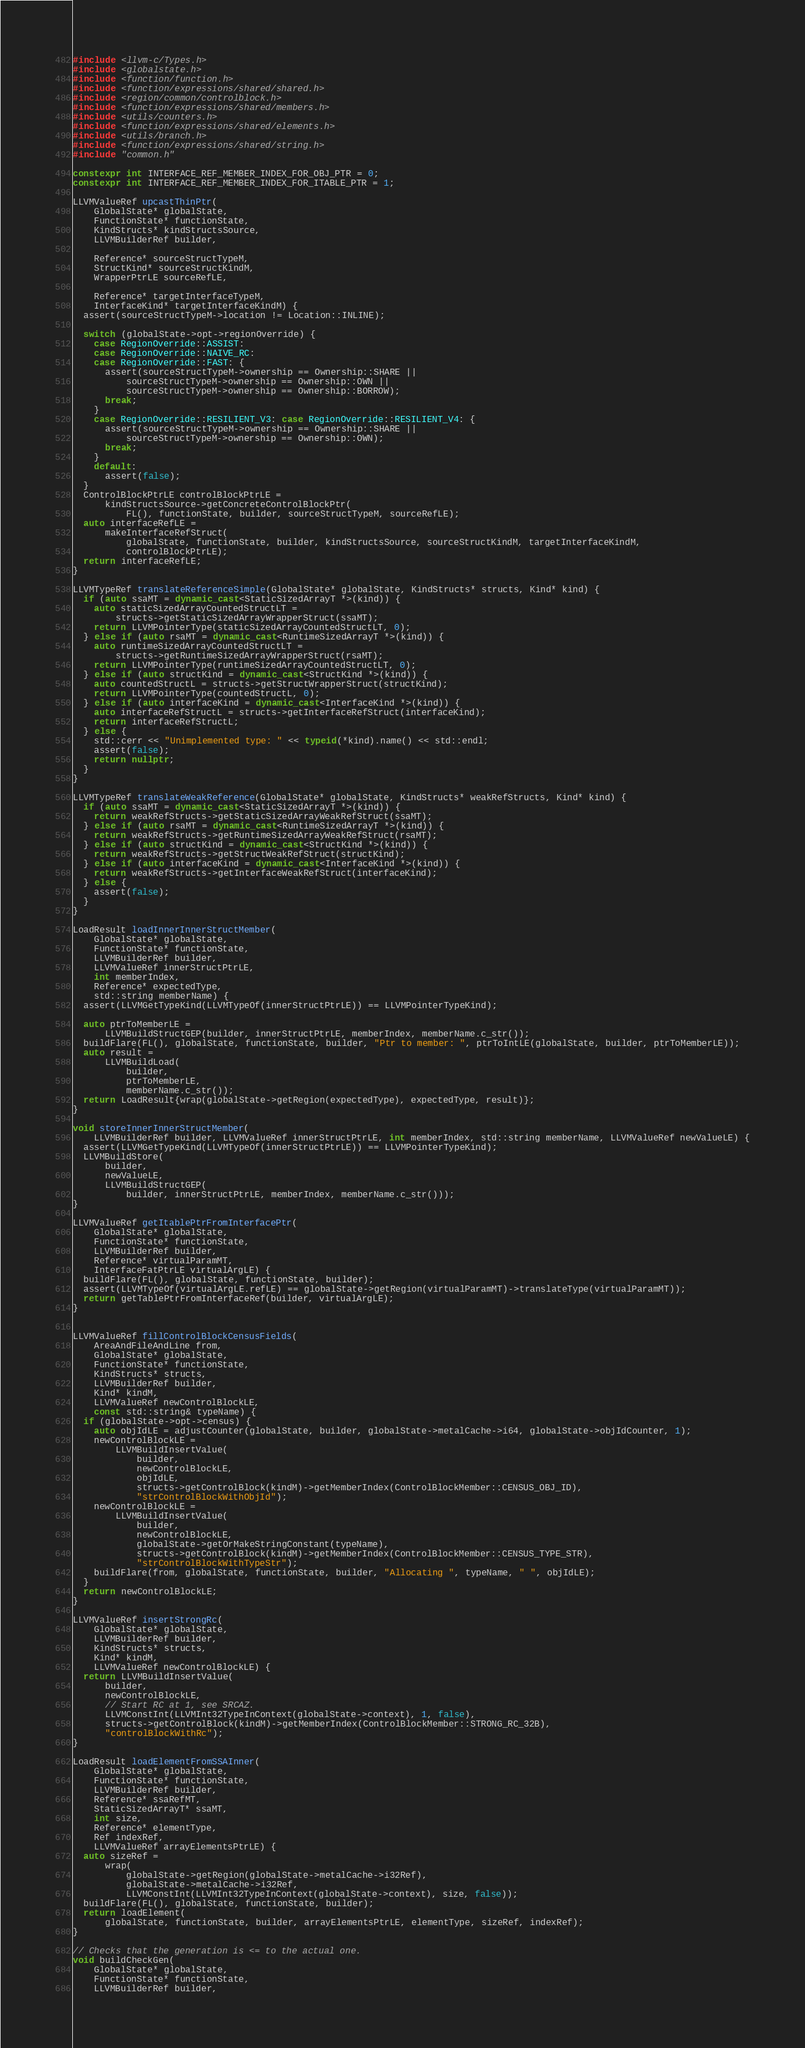Convert code to text. <code><loc_0><loc_0><loc_500><loc_500><_C++_>#include <llvm-c/Types.h>
#include <globalstate.h>
#include <function/function.h>
#include <function/expressions/shared/shared.h>
#include <region/common/controlblock.h>
#include <function/expressions/shared/members.h>
#include <utils/counters.h>
#include <function/expressions/shared/elements.h>
#include <utils/branch.h>
#include <function/expressions/shared/string.h>
#include "common.h"

constexpr int INTERFACE_REF_MEMBER_INDEX_FOR_OBJ_PTR = 0;
constexpr int INTERFACE_REF_MEMBER_INDEX_FOR_ITABLE_PTR = 1;

LLVMValueRef upcastThinPtr(
    GlobalState* globalState,
    FunctionState* functionState,
    KindStructs* kindStructsSource,
    LLVMBuilderRef builder,

    Reference* sourceStructTypeM,
    StructKind* sourceStructKindM,
    WrapperPtrLE sourceRefLE,

    Reference* targetInterfaceTypeM,
    InterfaceKind* targetInterfaceKindM) {
  assert(sourceStructTypeM->location != Location::INLINE);

  switch (globalState->opt->regionOverride) {
    case RegionOverride::ASSIST:
    case RegionOverride::NAIVE_RC:
    case RegionOverride::FAST: {
      assert(sourceStructTypeM->ownership == Ownership::SHARE ||
          sourceStructTypeM->ownership == Ownership::OWN ||
          sourceStructTypeM->ownership == Ownership::BORROW);
      break;
    }
    case RegionOverride::RESILIENT_V3: case RegionOverride::RESILIENT_V4: {
      assert(sourceStructTypeM->ownership == Ownership::SHARE ||
          sourceStructTypeM->ownership == Ownership::OWN);
      break;
    }
    default:
      assert(false);
  }
  ControlBlockPtrLE controlBlockPtrLE =
      kindStructsSource->getConcreteControlBlockPtr(
          FL(), functionState, builder, sourceStructTypeM, sourceRefLE);
  auto interfaceRefLE =
      makeInterfaceRefStruct(
          globalState, functionState, builder, kindStructsSource, sourceStructKindM, targetInterfaceKindM,
          controlBlockPtrLE);
  return interfaceRefLE;
}

LLVMTypeRef translateReferenceSimple(GlobalState* globalState, KindStructs* structs, Kind* kind) {
  if (auto ssaMT = dynamic_cast<StaticSizedArrayT *>(kind)) {
    auto staticSizedArrayCountedStructLT =
        structs->getStaticSizedArrayWrapperStruct(ssaMT);
    return LLVMPointerType(staticSizedArrayCountedStructLT, 0);
  } else if (auto rsaMT = dynamic_cast<RuntimeSizedArrayT *>(kind)) {
    auto runtimeSizedArrayCountedStructLT =
        structs->getRuntimeSizedArrayWrapperStruct(rsaMT);
    return LLVMPointerType(runtimeSizedArrayCountedStructLT, 0);
  } else if (auto structKind = dynamic_cast<StructKind *>(kind)) {
    auto countedStructL = structs->getStructWrapperStruct(structKind);
    return LLVMPointerType(countedStructL, 0);
  } else if (auto interfaceKind = dynamic_cast<InterfaceKind *>(kind)) {
    auto interfaceRefStructL = structs->getInterfaceRefStruct(interfaceKind);
    return interfaceRefStructL;
  } else {
    std::cerr << "Unimplemented type: " << typeid(*kind).name() << std::endl;
    assert(false);
    return nullptr;
  }
}

LLVMTypeRef translateWeakReference(GlobalState* globalState, KindStructs* weakRefStructs, Kind* kind) {
  if (auto ssaMT = dynamic_cast<StaticSizedArrayT *>(kind)) {
    return weakRefStructs->getStaticSizedArrayWeakRefStruct(ssaMT);
  } else if (auto rsaMT = dynamic_cast<RuntimeSizedArrayT *>(kind)) {
    return weakRefStructs->getRuntimeSizedArrayWeakRefStruct(rsaMT);
  } else if (auto structKind = dynamic_cast<StructKind *>(kind)) {
    return weakRefStructs->getStructWeakRefStruct(structKind);
  } else if (auto interfaceKind = dynamic_cast<InterfaceKind *>(kind)) {
    return weakRefStructs->getInterfaceWeakRefStruct(interfaceKind);
  } else {
    assert(false);
  }
}

LoadResult loadInnerInnerStructMember(
    GlobalState* globalState,
    FunctionState* functionState,
    LLVMBuilderRef builder,
    LLVMValueRef innerStructPtrLE,
    int memberIndex,
    Reference* expectedType,
    std::string memberName) {
  assert(LLVMGetTypeKind(LLVMTypeOf(innerStructPtrLE)) == LLVMPointerTypeKind);

  auto ptrToMemberLE =
      LLVMBuildStructGEP(builder, innerStructPtrLE, memberIndex, memberName.c_str());
  buildFlare(FL(), globalState, functionState, builder, "Ptr to member: ", ptrToIntLE(globalState, builder, ptrToMemberLE));
  auto result =
      LLVMBuildLoad(
          builder,
          ptrToMemberLE,
          memberName.c_str());
  return LoadResult{wrap(globalState->getRegion(expectedType), expectedType, result)};
}

void storeInnerInnerStructMember(
    LLVMBuilderRef builder, LLVMValueRef innerStructPtrLE, int memberIndex, std::string memberName, LLVMValueRef newValueLE) {
  assert(LLVMGetTypeKind(LLVMTypeOf(innerStructPtrLE)) == LLVMPointerTypeKind);
  LLVMBuildStore(
      builder,
      newValueLE,
      LLVMBuildStructGEP(
          builder, innerStructPtrLE, memberIndex, memberName.c_str()));
}

LLVMValueRef getItablePtrFromInterfacePtr(
    GlobalState* globalState,
    FunctionState* functionState,
    LLVMBuilderRef builder,
    Reference* virtualParamMT,
    InterfaceFatPtrLE virtualArgLE) {
  buildFlare(FL(), globalState, functionState, builder);
  assert(LLVMTypeOf(virtualArgLE.refLE) == globalState->getRegion(virtualParamMT)->translateType(virtualParamMT));
  return getTablePtrFromInterfaceRef(builder, virtualArgLE);
}


LLVMValueRef fillControlBlockCensusFields(
    AreaAndFileAndLine from,
    GlobalState* globalState,
    FunctionState* functionState,
    KindStructs* structs,
    LLVMBuilderRef builder,
    Kind* kindM,
    LLVMValueRef newControlBlockLE,
    const std::string& typeName) {
  if (globalState->opt->census) {
    auto objIdLE = adjustCounter(globalState, builder, globalState->metalCache->i64, globalState->objIdCounter, 1);
    newControlBlockLE =
        LLVMBuildInsertValue(
            builder,
            newControlBlockLE,
            objIdLE,
            structs->getControlBlock(kindM)->getMemberIndex(ControlBlockMember::CENSUS_OBJ_ID),
            "strControlBlockWithObjId");
    newControlBlockLE =
        LLVMBuildInsertValue(
            builder,
            newControlBlockLE,
            globalState->getOrMakeStringConstant(typeName),
            structs->getControlBlock(kindM)->getMemberIndex(ControlBlockMember::CENSUS_TYPE_STR),
            "strControlBlockWithTypeStr");
    buildFlare(from, globalState, functionState, builder, "Allocating ", typeName, " ", objIdLE);
  }
  return newControlBlockLE;
}

LLVMValueRef insertStrongRc(
    GlobalState* globalState,
    LLVMBuilderRef builder,
    KindStructs* structs,
    Kind* kindM,
    LLVMValueRef newControlBlockLE) {
  return LLVMBuildInsertValue(
      builder,
      newControlBlockLE,
      // Start RC at 1, see SRCAZ.
      LLVMConstInt(LLVMInt32TypeInContext(globalState->context), 1, false),
      structs->getControlBlock(kindM)->getMemberIndex(ControlBlockMember::STRONG_RC_32B),
      "controlBlockWithRc");
}

LoadResult loadElementFromSSAInner(
    GlobalState* globalState,
    FunctionState* functionState,
    LLVMBuilderRef builder,
    Reference* ssaRefMT,
    StaticSizedArrayT* ssaMT,
    int size,
    Reference* elementType,
    Ref indexRef,
    LLVMValueRef arrayElementsPtrLE) {
  auto sizeRef =
      wrap(
          globalState->getRegion(globalState->metalCache->i32Ref),
          globalState->metalCache->i32Ref,
          LLVMConstInt(LLVMInt32TypeInContext(globalState->context), size, false));
  buildFlare(FL(), globalState, functionState, builder);
  return loadElement(
      globalState, functionState, builder, arrayElementsPtrLE, elementType, sizeRef, indexRef);
}

// Checks that the generation is <= to the actual one.
void buildCheckGen(
    GlobalState* globalState,
    FunctionState* functionState,
    LLVMBuilderRef builder,</code> 